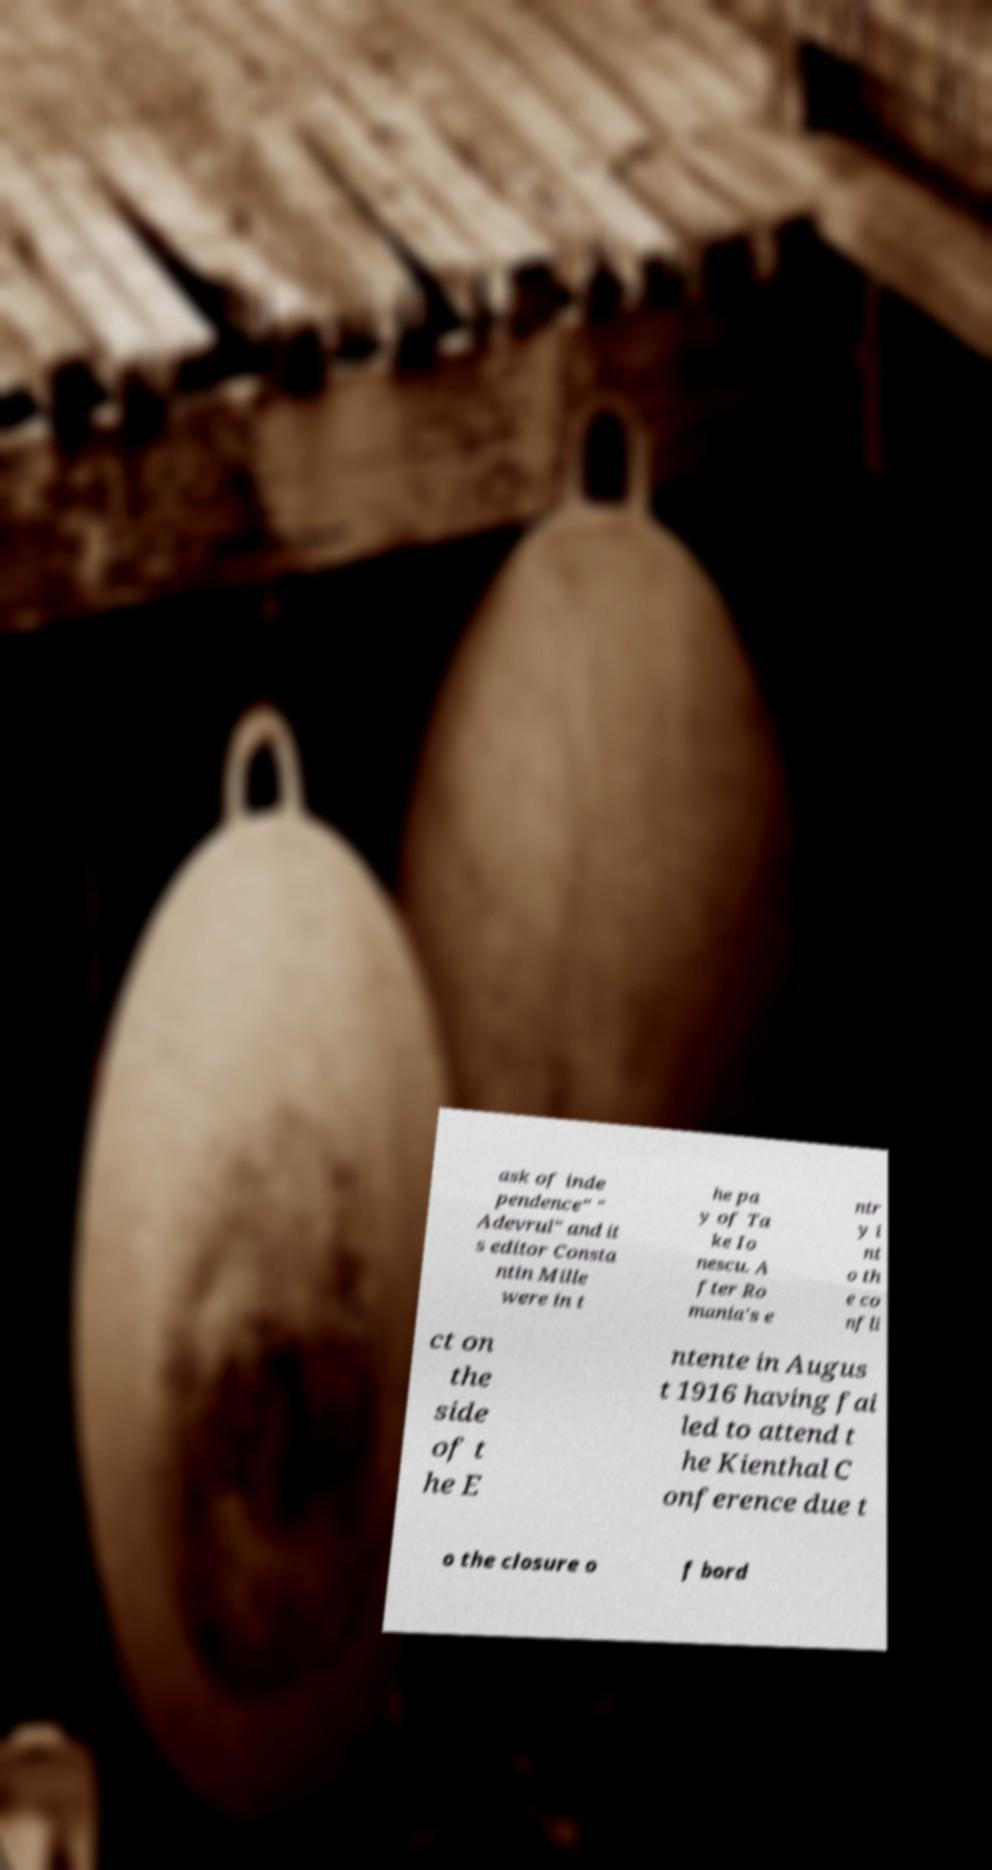I need the written content from this picture converted into text. Can you do that? ask of inde pendence" " Adevrul" and it s editor Consta ntin Mille were in t he pa y of Ta ke Io nescu. A fter Ro mania's e ntr y i nt o th e co nfli ct on the side of t he E ntente in Augus t 1916 having fai led to attend t he Kienthal C onference due t o the closure o f bord 